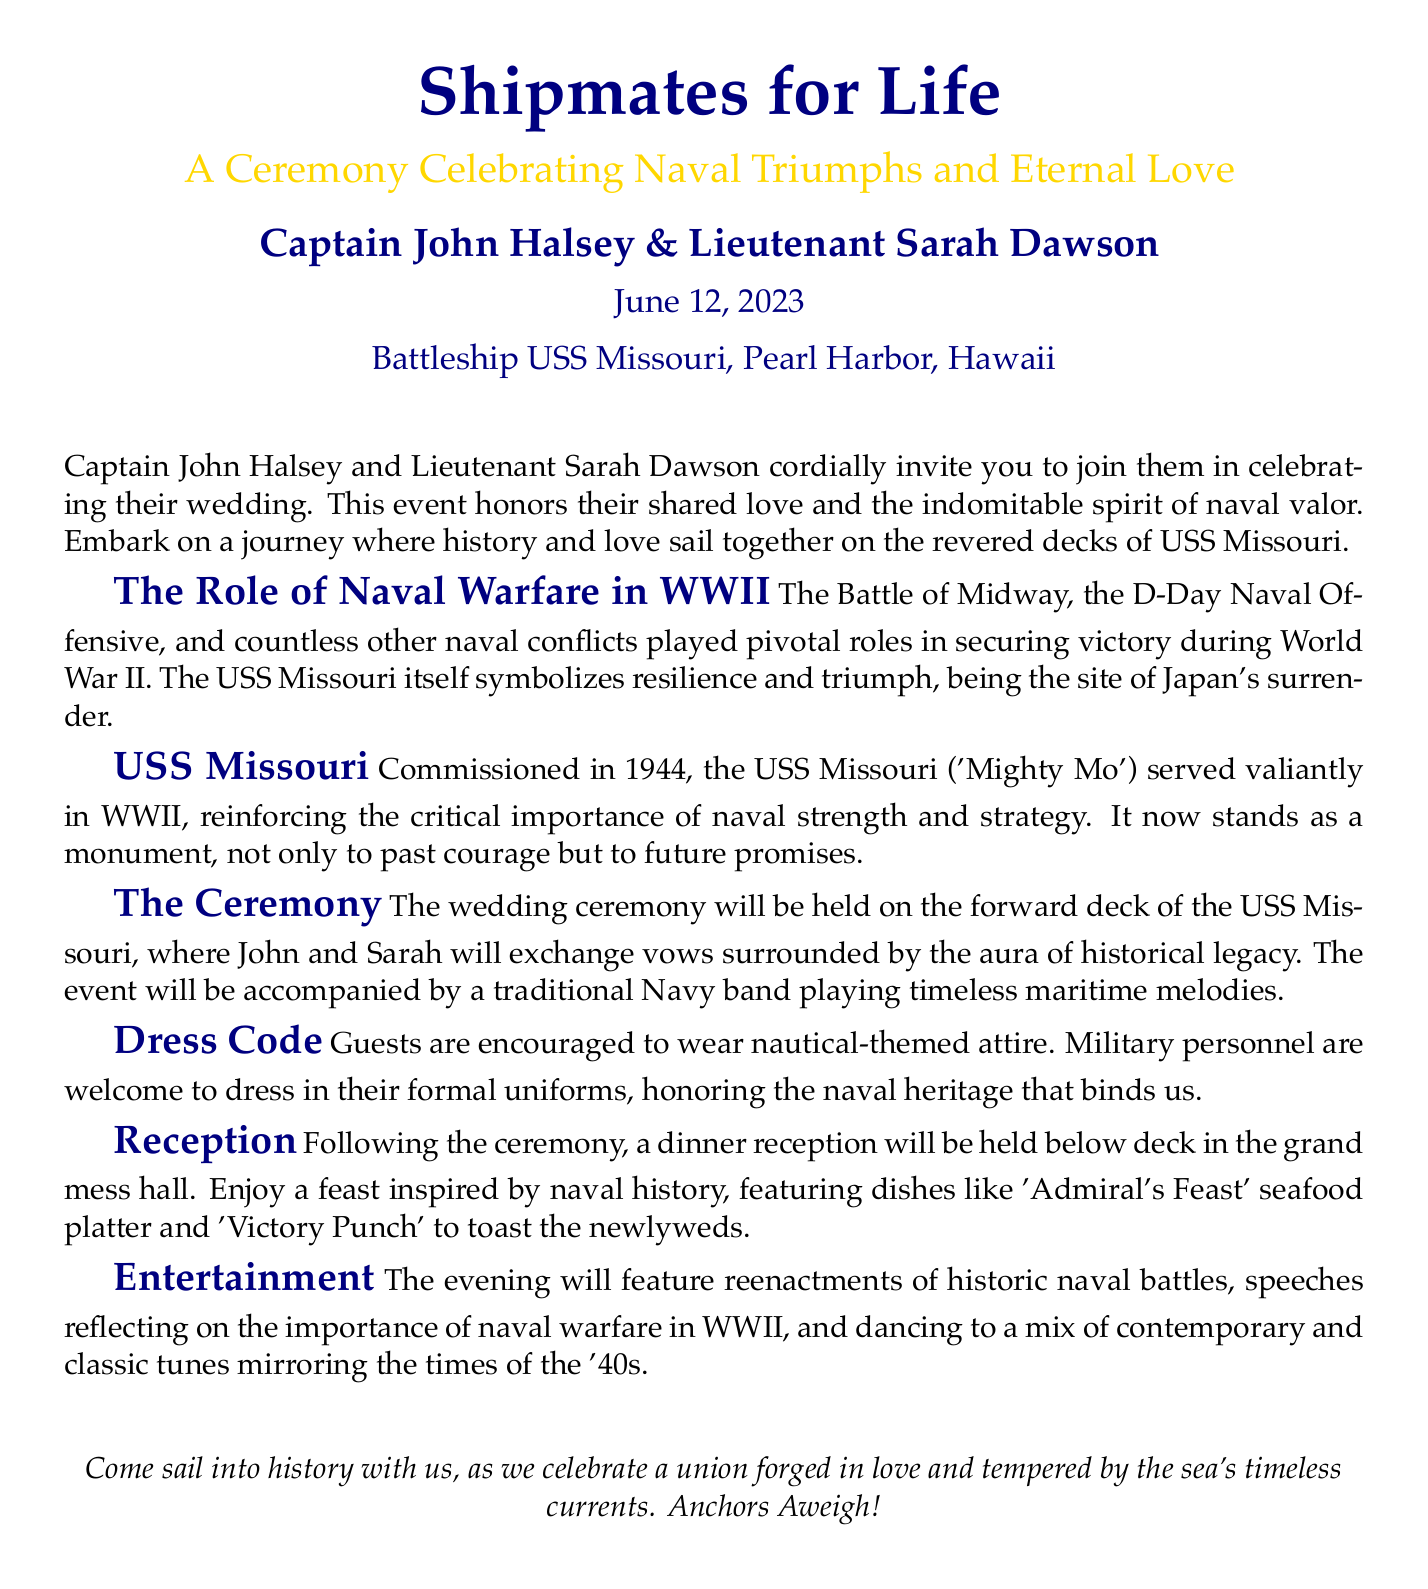What is the name of the ship? The name of the ship mentioned in the document is the USS Missouri.
Answer: USS Missouri Who are the couple getting married? The couple getting married are Captain John Halsey and Lieutenant Sarah Dawson.
Answer: Captain John Halsey and Lieutenant Sarah Dawson What date is the wedding ceremony? The wedding ceremony is scheduled for June 12, 2023.
Answer: June 12, 2023 Where will the ceremony take place? The ceremony will take place on the forward deck of the USS Missouri.
Answer: forward deck of the USS Missouri What type of attire is encouraged for guests? Guests are encouraged to wear nautical-themed attire.
Answer: nautical-themed attire What will be served at the reception? The reception will feature an 'Admiral's Feast' seafood platter and 'Victory Punch.'
Answer: 'Admiral's Feast' seafood platter and 'Victory Punch' What type of band will accompany the ceremony? A traditional Navy band will accompany the ceremony.
Answer: traditional Navy band What kind of entertainment will be provided during the evening? The evening will feature reenactments of historic naval battles.
Answer: reenactments of historic naval battles What symbolizes resilience and triumph in the document? The USS Missouri symbolizes resilience and triumph.
Answer: USS Missouri 